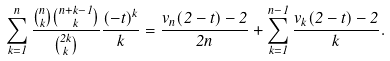Convert formula to latex. <formula><loc_0><loc_0><loc_500><loc_500>\sum _ { k = 1 } ^ { n } \frac { \binom { n } { k } \binom { n + k - 1 } { k } } { \binom { 2 k } { k } } \frac { ( - t ) ^ { k } } { k } = \frac { v _ { n } ( 2 - t ) - 2 } { 2 n } + \sum _ { k = 1 } ^ { n - 1 } \frac { v _ { k } ( 2 - t ) - 2 } { k } .</formula> 